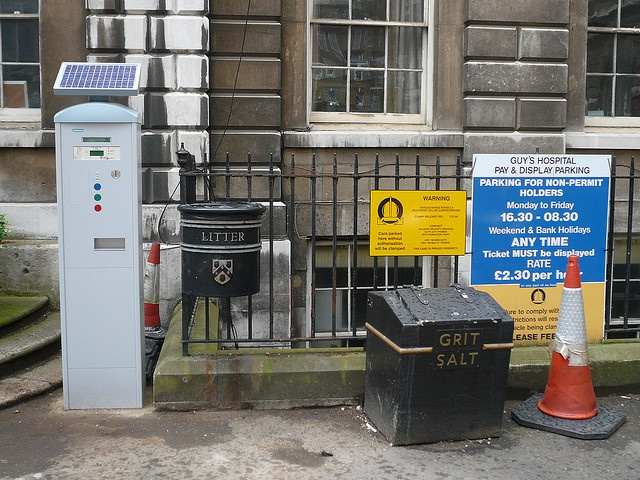Describe the objects in this image and their specific colors. I can see a parking meter in blue, lightgray, and darkgray tones in this image. 